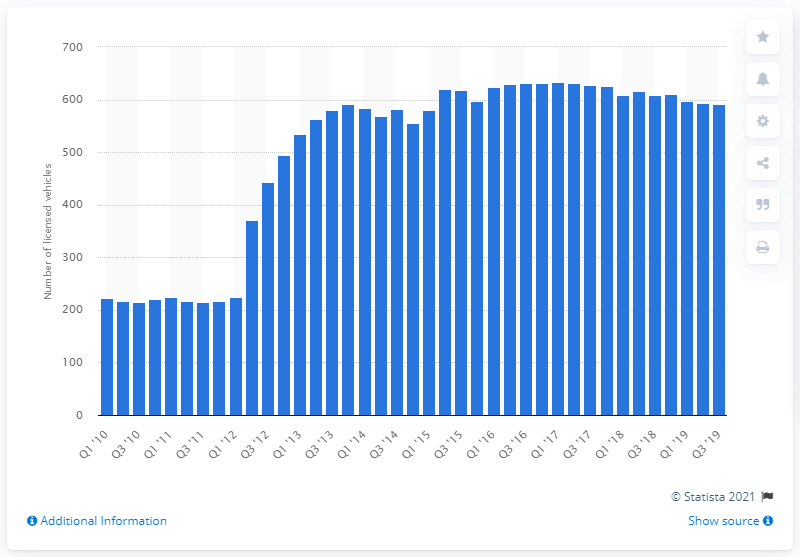Outline some significant characteristics in this image. In the first quarter of 2017, a total of 634 quadricycles were licensed. During the period of 2010 to 2019, the number of quadricycle microcars in the UK reached 592 units. 